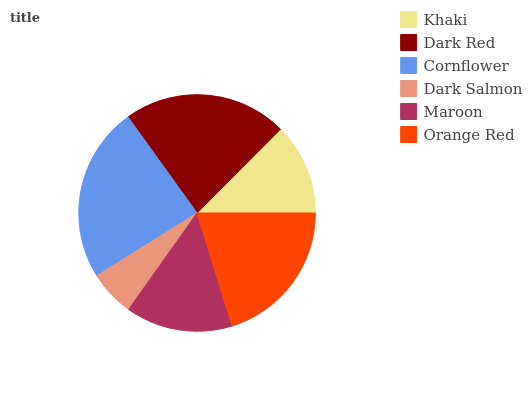Is Dark Salmon the minimum?
Answer yes or no. Yes. Is Cornflower the maximum?
Answer yes or no. Yes. Is Dark Red the minimum?
Answer yes or no. No. Is Dark Red the maximum?
Answer yes or no. No. Is Dark Red greater than Khaki?
Answer yes or no. Yes. Is Khaki less than Dark Red?
Answer yes or no. Yes. Is Khaki greater than Dark Red?
Answer yes or no. No. Is Dark Red less than Khaki?
Answer yes or no. No. Is Orange Red the high median?
Answer yes or no. Yes. Is Maroon the low median?
Answer yes or no. Yes. Is Dark Salmon the high median?
Answer yes or no. No. Is Khaki the low median?
Answer yes or no. No. 